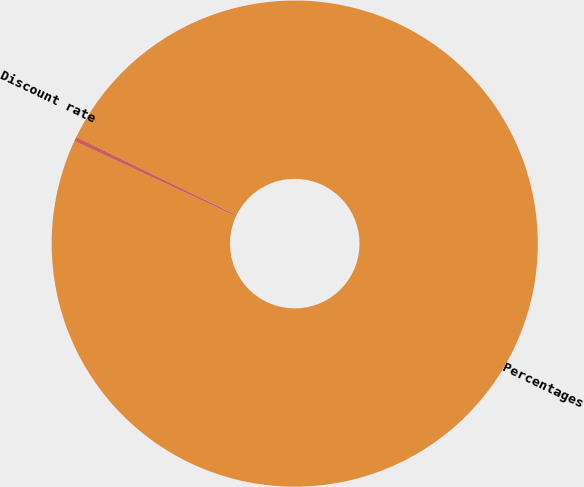Convert chart. <chart><loc_0><loc_0><loc_500><loc_500><pie_chart><fcel>Percentages<fcel>Discount rate<nl><fcel>99.71%<fcel>0.29%<nl></chart> 